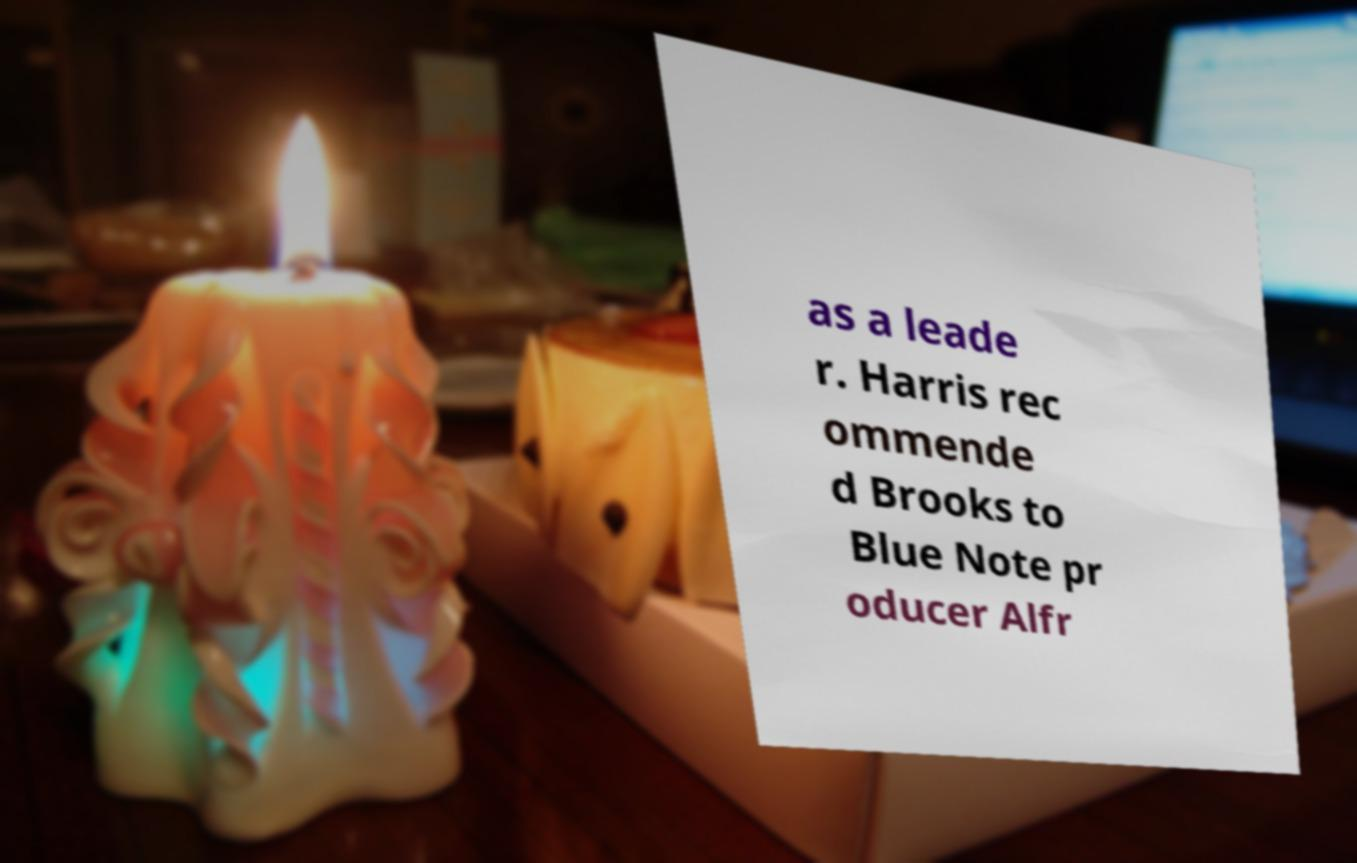Can you read and provide the text displayed in the image?This photo seems to have some interesting text. Can you extract and type it out for me? as a leade r. Harris rec ommende d Brooks to Blue Note pr oducer Alfr 